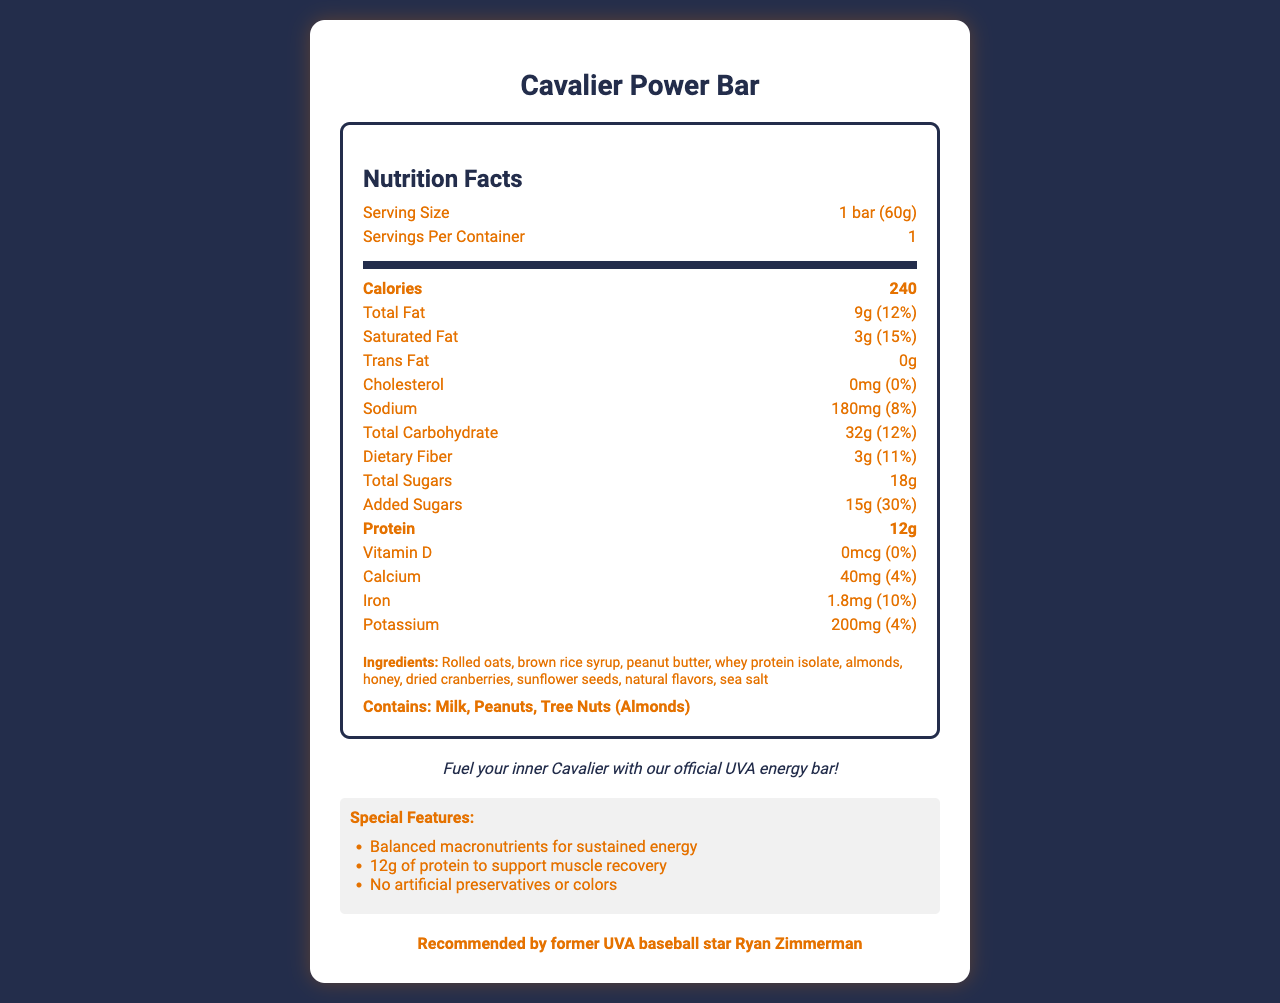What is the serving size of the Cavalier Power Bar? The document states that the serving size is 1 bar weighing 60 grams.
Answer: 1 bar (60g) How many calories are in one serving of the Cavalier Power Bar? The document specifies that one bar contains 240 calories.
Answer: 240 calories What is the amount of protein in the Cavalier Power Bar? The Nutrition Facts section displays that each bar contains 12 grams of protein.
Answer: 12g How much total fat does the Cavalier Power Bar contain? The document lists the total fat content of the bar as 9 grams.
Answer: 9g What are the allergens present in the Cavalier Power Bar? The allergens section indicates that the bar contains milk, peanuts, and tree nuts (almonds).
Answer: Milk, Peanuts, Tree Nuts (Almonds) What percentage of the daily value is the added sugars in the Cavalier Power Bar? A. 20% B. 25% C. 30% D. 35% The label indicates that added sugars make up 30% of the daily value.
Answer: C What is the sodium content in the Cavalier Power Bar? A. 150mg B. 180mg C. 200mg D. 250mg The bar contains 180 milligrams of sodium, as stated in the nutritional details.
Answer: B Does the Cavalier Power Bar contain any trans fat? The document clearly states that the bar contains 0 grams of trans fat.
Answer: No Is the Cavalier Power Bar recommended by any athlete? The document mentions that it is recommended by former UVA baseball star Ryan Zimmerman.
Answer: Yes Summarize the main idea of the document. The document provides detailed nutritional information about the Cavalier Power Bar, highlights its ingredients and special features, and emphasizes its athletic endorsement and eco-friendly packaging.
Answer: The Cavalier Power Bar is a branded energy bar available at Scott Stadium's concession stands. It offers balanced macronutrients, contains 12g of protein, and is made with no artificial preservatives or colors. The bar is endorsed by a former UVA baseball star, uses locally grown ingredients, and features a recyclable wrapper. What is the vitamin D content in the Cavalier Power Bar? The document states that the bar contains 0 micrograms of vitamin D.
Answer: 0mcg Where can the Cavalier Power Bar be purchased? The document specifies that the bar is available at all Scott Stadium concession stands.
Answer: Scott Stadium concession stands Is the wrapper of the Cavalier Power Bar recyclable? It is mentioned that the wrapper is recyclable at all UVA athletic facilities.
Answer: Yes How much calcium is in the Cavalier Power Bar? The nutritional information indicates that the bar contains 40 milligrams of calcium.
Answer: 40mg Who manufactures the Cavalier Power Bar? The document does not provide information about the manufacturer of the bar.
Answer: Not enough information 